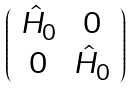<formula> <loc_0><loc_0><loc_500><loc_500>\left ( \begin{array} { c c } \hat { H } _ { 0 } & 0 \\ 0 & \hat { H } _ { 0 } \end{array} \right )</formula> 